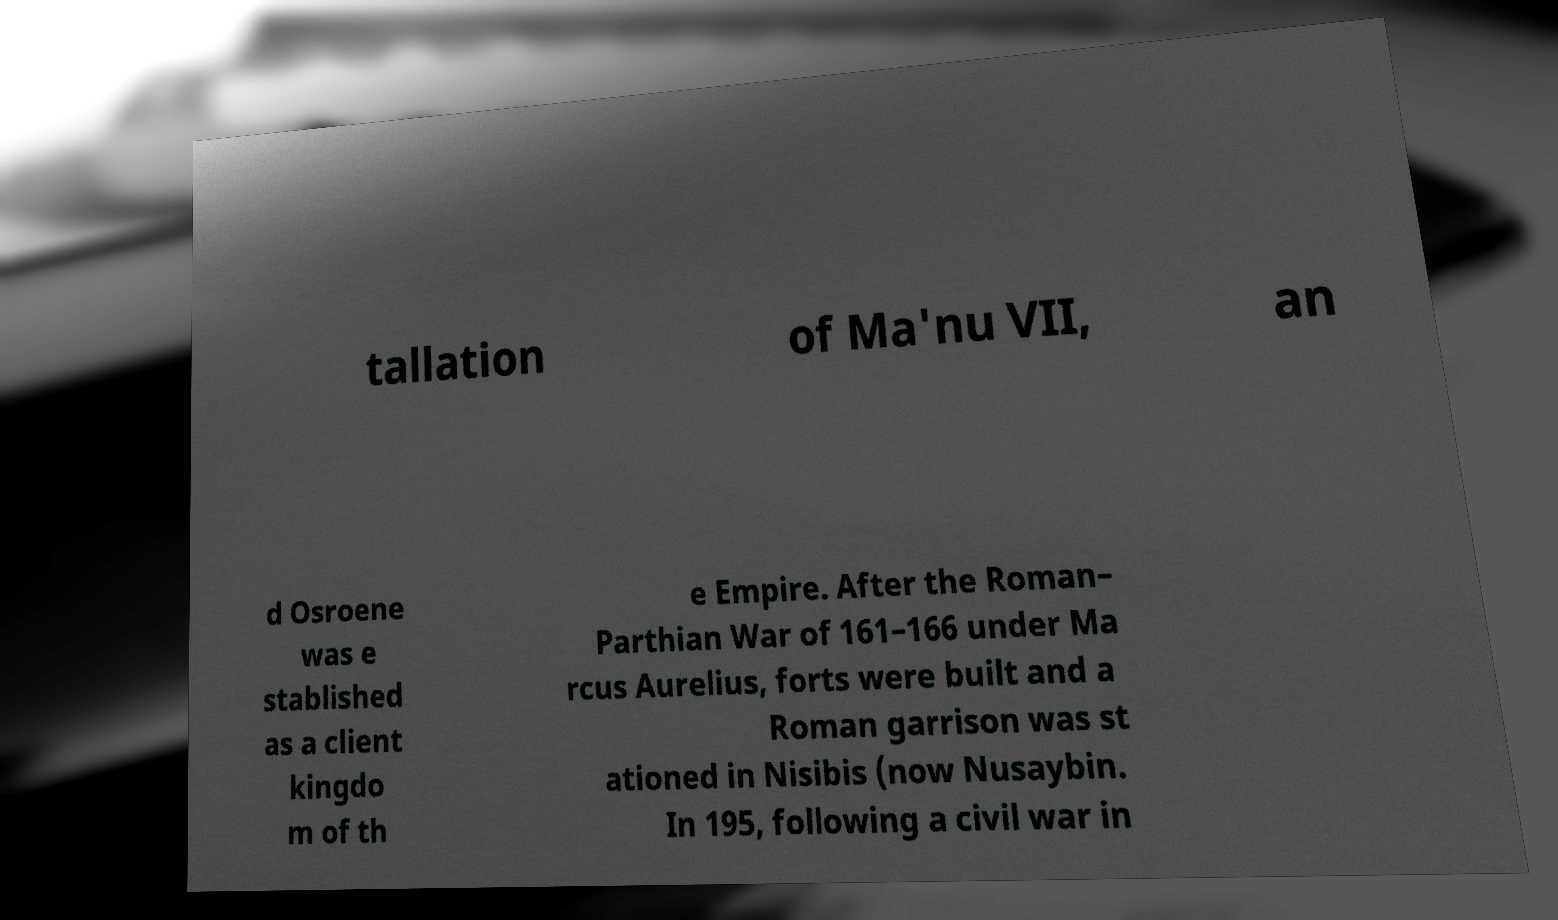There's text embedded in this image that I need extracted. Can you transcribe it verbatim? tallation of Ma'nu VII, an d Osroene was e stablished as a client kingdo m of th e Empire. After the Roman– Parthian War of 161–166 under Ma rcus Aurelius, forts were built and a Roman garrison was st ationed in Nisibis (now Nusaybin. In 195, following a civil war in 